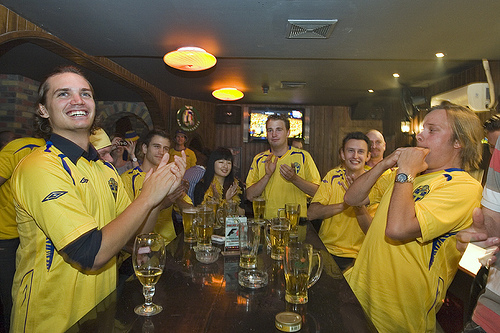<image>
Is there a man behind the table? Yes. From this viewpoint, the man is positioned behind the table, with the table partially or fully occluding the man. Where is the woman in relation to the man? Is it to the right of the man? No. The woman is not to the right of the man. The horizontal positioning shows a different relationship. Where is the man in relation to the glass? Is it above the glass? No. The man is not positioned above the glass. The vertical arrangement shows a different relationship. 